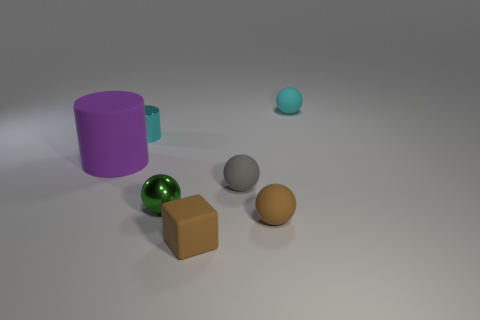Subtract all cyan matte spheres. How many spheres are left? 3 Subtract all gray cylinders. Subtract all red cubes. How many cylinders are left? 2 Add 2 cyan matte things. How many objects exist? 9 Subtract all blocks. How many objects are left? 6 Subtract all small green things. Subtract all small blue metallic balls. How many objects are left? 6 Add 4 tiny brown rubber things. How many tiny brown rubber things are left? 6 Add 5 small brown cubes. How many small brown cubes exist? 6 Subtract 0 red blocks. How many objects are left? 7 